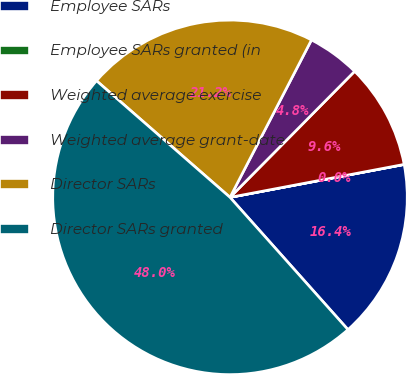<chart> <loc_0><loc_0><loc_500><loc_500><pie_chart><fcel>Employee SARs<fcel>Employee SARs granted (in<fcel>Weighted average exercise<fcel>Weighted average grant-date<fcel>Director SARs<fcel>Director SARs granted<nl><fcel>16.38%<fcel>0.01%<fcel>9.61%<fcel>4.81%<fcel>21.18%<fcel>48.02%<nl></chart> 